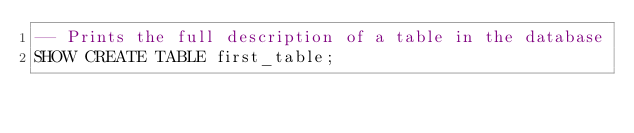Convert code to text. <code><loc_0><loc_0><loc_500><loc_500><_SQL_>-- Prints the full description of a table in the database
SHOW CREATE TABLE first_table;
</code> 